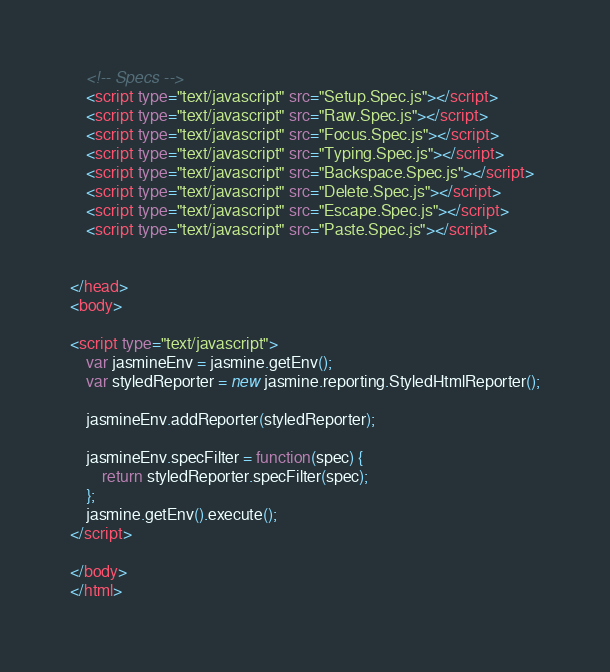<code> <loc_0><loc_0><loc_500><loc_500><_HTML_>    <!-- Specs -->
    <script type="text/javascript" src="Setup.Spec.js"></script>
	<script type="text/javascript" src="Raw.Spec.js"></script>
    <script type="text/javascript" src="Focus.Spec.js"></script>
    <script type="text/javascript" src="Typing.Spec.js"></script>
    <script type="text/javascript" src="Backspace.Spec.js"></script>
    <script type="text/javascript" src="Delete.Spec.js"></script>
	<script type="text/javascript" src="Escape.Spec.js"></script>
    <script type="text/javascript" src="Paste.Spec.js"></script>


</head>
<body>

<script type="text/javascript">
    var jasmineEnv = jasmine.getEnv();
    var styledReporter = new jasmine.reporting.StyledHtmlReporter();

    jasmineEnv.addReporter(styledReporter);

    jasmineEnv.specFilter = function(spec) {
        return styledReporter.specFilter(spec);
    };
    jasmine.getEnv().execute();
</script>

</body>
</html>
</code> 